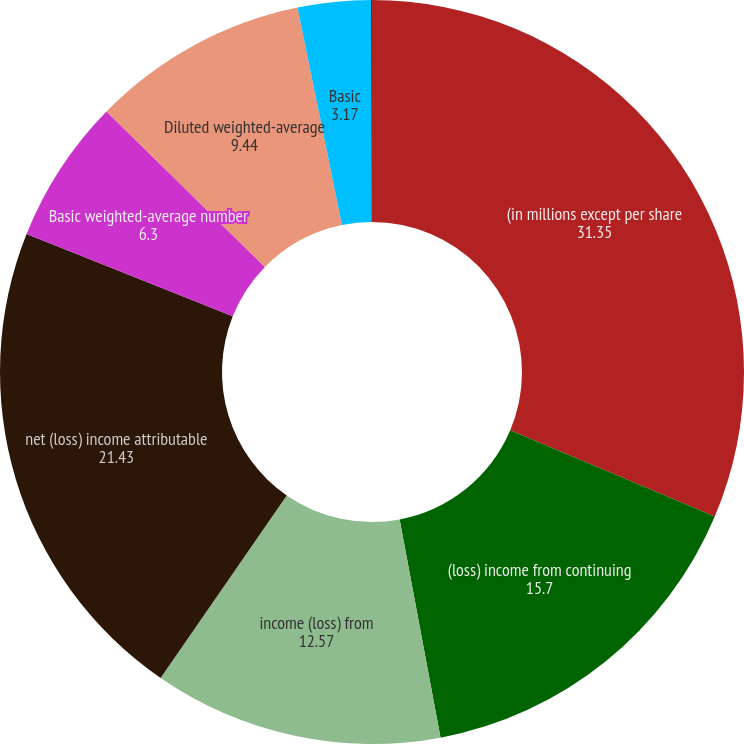Convert chart to OTSL. <chart><loc_0><loc_0><loc_500><loc_500><pie_chart><fcel>(in millions except per share<fcel>(loss) income from continuing<fcel>income (loss) from<fcel>net (loss) income attributable<fcel>Basic weighted-average number<fcel>Diluted weighted-average<fcel>Basic<fcel>Diluted<nl><fcel>31.35%<fcel>15.7%<fcel>12.57%<fcel>21.43%<fcel>6.3%<fcel>9.44%<fcel>3.17%<fcel>0.04%<nl></chart> 